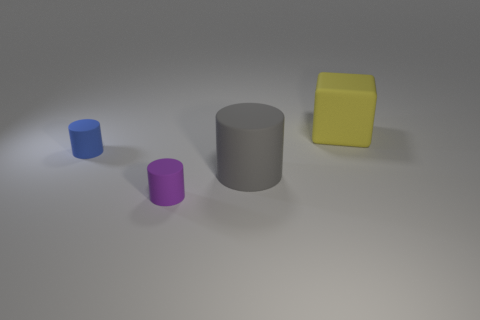Subtract all green cubes. Subtract all purple cylinders. How many cubes are left? 1 Add 4 gray rubber objects. How many objects exist? 8 Subtract all blocks. How many objects are left? 3 Subtract 1 yellow cubes. How many objects are left? 3 Subtract all large purple cylinders. Subtract all tiny blue cylinders. How many objects are left? 3 Add 4 tiny purple rubber things. How many tiny purple rubber things are left? 5 Add 1 tiny blue metallic things. How many tiny blue metallic things exist? 1 